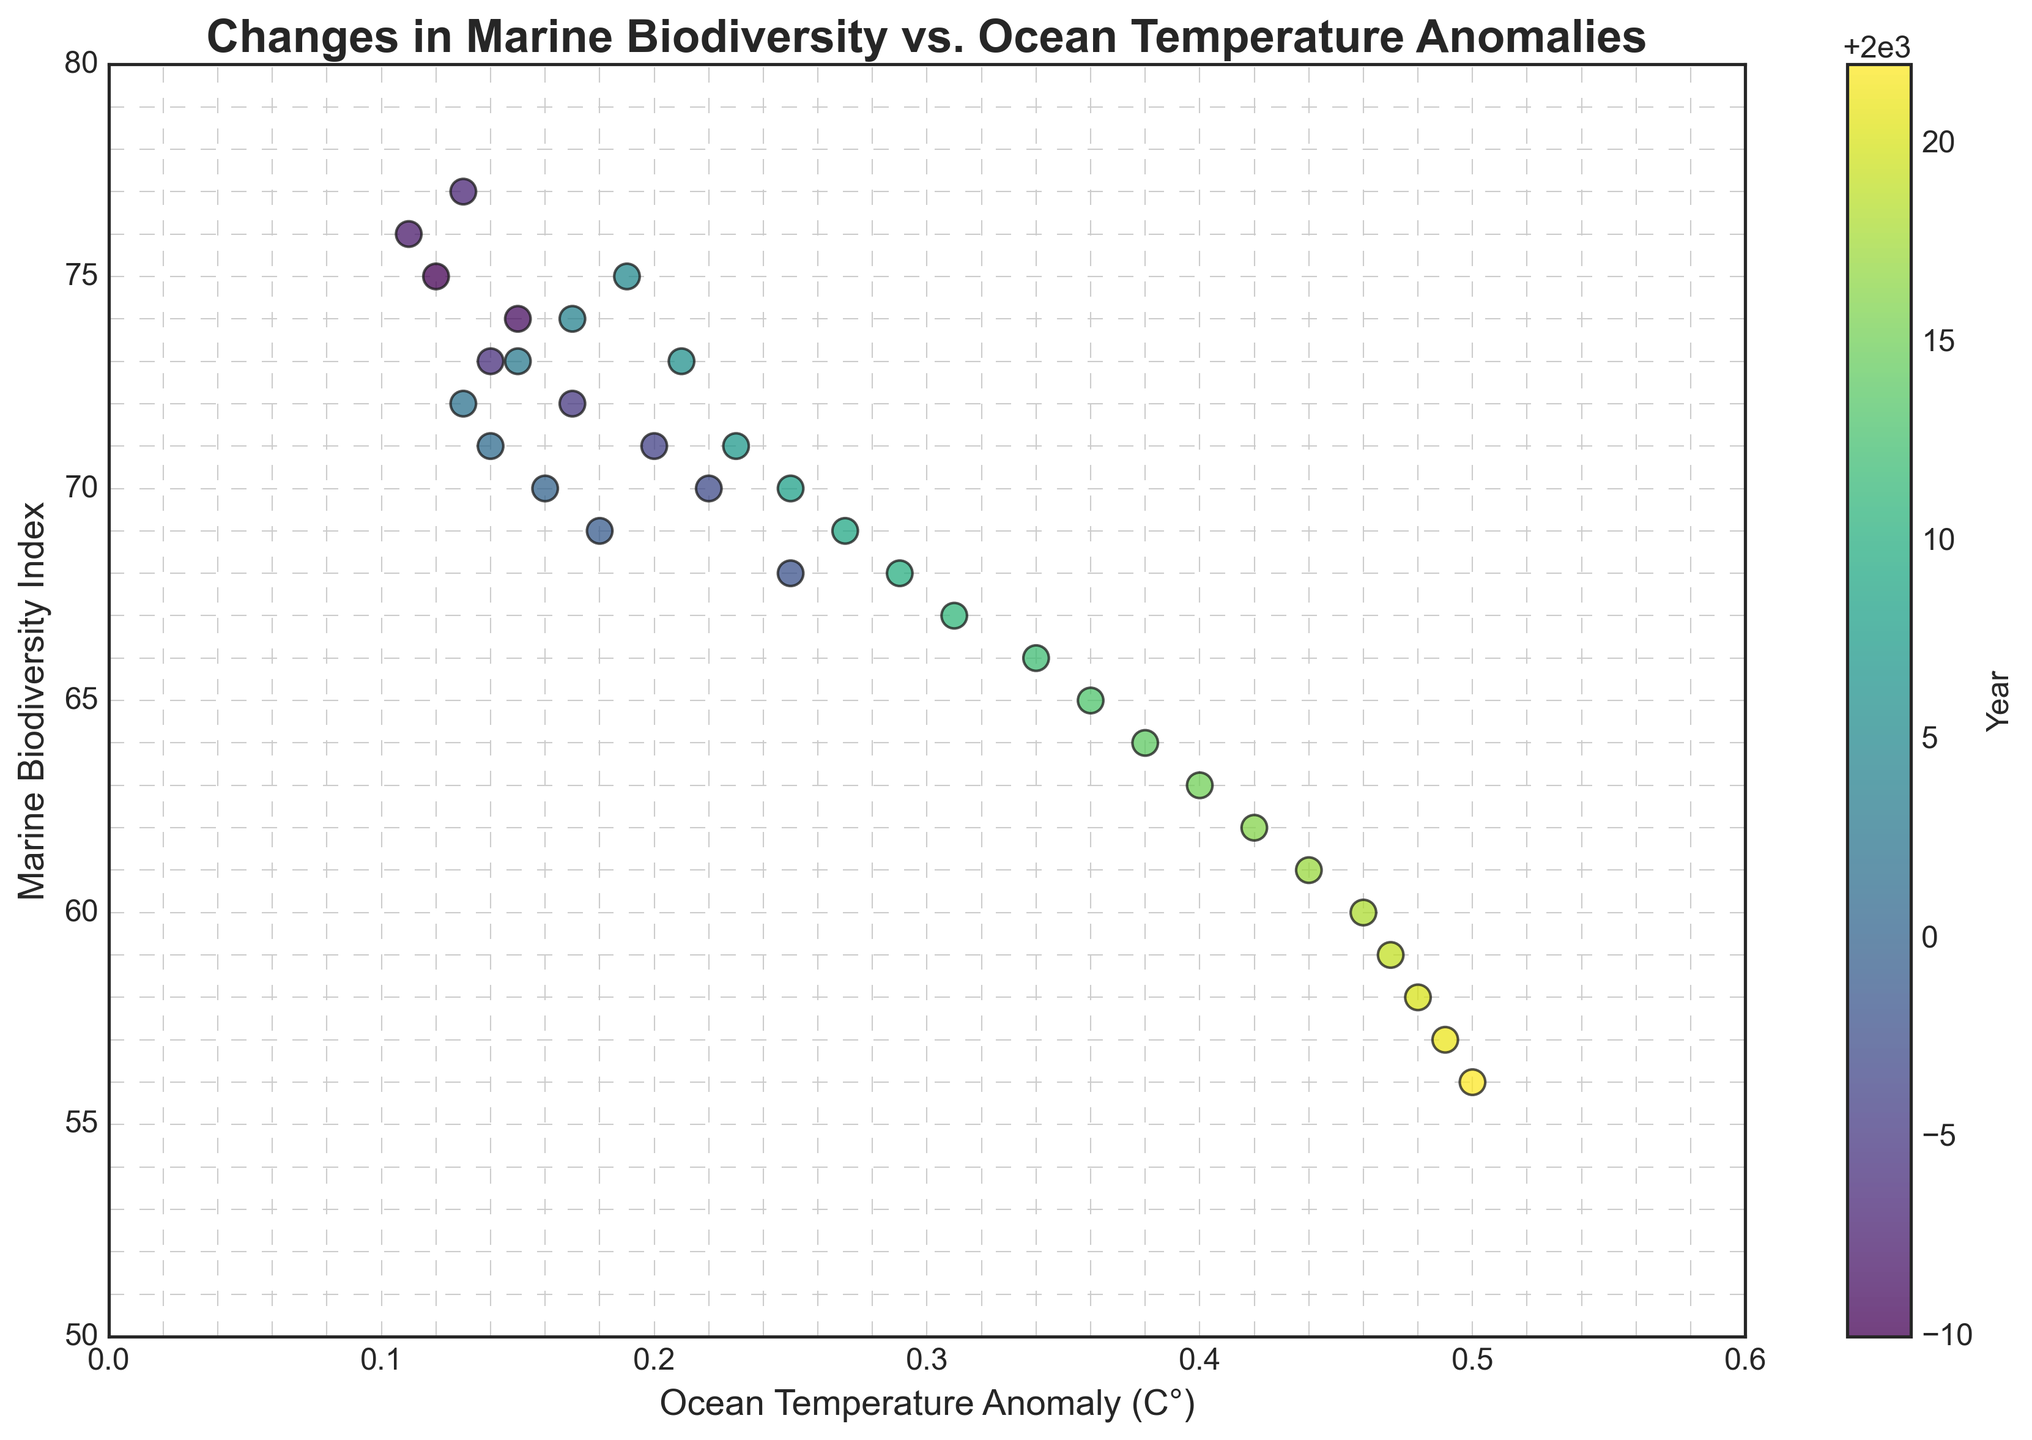What is the overall trend observed in marine biodiversity as ocean temperature anomalies increase? By examining the scatter plot, the marine biodiversity index generally decreases as the ocean temperature anomaly increases. This trend indicates a negative correlation between marine biodiversity and ocean temperature anomalies.
Answer: Decreasing trend What is the marine biodiversity index in the year with the highest ocean temperature anomaly? The color bar shows that the highest ocean temperature anomaly occurs in 2022. The marine biodiversity index for this year is around 56.
Answer: 56 Compare the marine biodiversity index between the years with the lowest and highest ocean temperature anomalies. The year with the lowest temperature anomaly (around 0.11) is 1992, having a marine biodiversity index of 76. The year with the highest temperature anomaly (around 0.50) is 2022, with a marine biodiversity index of 56. Therefore, the index has decreased by 20 points.
Answer: 20 points decrease Which year shows a higher marine biodiversity index: 2000 or 2005? From the scatter plot, 2000 has a marine biodiversity index of 70, while 2005 shows an index of 75. Hence, 2005 has a higher marine biodiversity index.
Answer: 2005 What is the average ocean temperature anomaly for the years with a marine biodiversity index below 65? Identifying the points with a marine biodiversity index below 65 (years from 2013 to 2022), we sum the temperature anomalies for these years and divide by the count of years: (0.36 + 0.38 + 0.40 + 0.42 + 0.44 + 0.46 + 0.47 + 0.48 + 0.49 + 0.50) / 10 = 0.44.
Answer: 0.44 How does the color gradient help interpret the change in data over years? The color gradient from blue to green to yellow visually represents the passage of time from older years to more recent years. This gradient helps see that more recent years (in yellow) are associated with higher temperature anomalies and lower biodiversity indices compared to earlier years (in blue).
Answer: Shows time progression What is the discrepancy between the marine biodiversity index of 1990 and 2020? According to the scatter plot, 1990 has a marine biodiversity index of 75, and 2020 has an index of 58. The difference between these indices is 75 - 58 = 17.
Answer: 17 Which year has the highest marine biodiversity index when the ocean temperature anomaly is above 0.3°C? The scatter plot indicates that the highest marine biodiversity index when ocean temperature anomalies are above 0.3°C is around 31, which corresponds to the year 2011.
Answer: 2011 How does the marine biodiversity index in 2010 compare to that in 1998? The scatter plot shows that the marine biodiversity index in 2010 is 68, while in 1998 it is also 68. Therefore, the biodiversity index is the same for both years.
Answer: Same Is there a year where the biodiversity index increases as compared to its previous year despite a rise in temperature anomaly? Examine the scatter plot sequences, we notice between 1998 (index 68, anomaly 0.25) and 1999 (index 69, anomaly 0.18), marine biodiversity index increases despite the anomaly decreasing.
Answer: 1999 